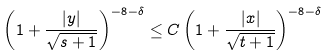<formula> <loc_0><loc_0><loc_500><loc_500>\left ( 1 + \frac { | y | } { \sqrt { s + 1 } } \right ) ^ { - 8 - \delta } \leq C \left ( 1 + \frac { | x | } { \sqrt { t + 1 } } \right ) ^ { - 8 - \delta }</formula> 